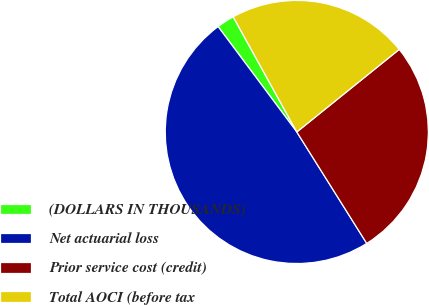Convert chart to OTSL. <chart><loc_0><loc_0><loc_500><loc_500><pie_chart><fcel>(DOLLARS IN THOUSANDS)<fcel>Net actuarial loss<fcel>Prior service cost (credit)<fcel>Total AOCI (before tax<nl><fcel>2.18%<fcel>48.71%<fcel>26.88%<fcel>22.23%<nl></chart> 